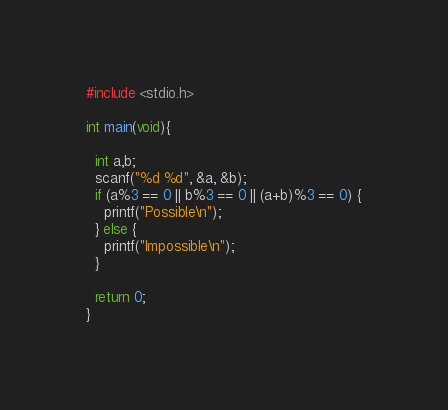Convert code to text. <code><loc_0><loc_0><loc_500><loc_500><_C_>#include <stdio.h>

int main(void){

  int a,b;
  scanf("%d %d", &a, &b);
  if (a%3 == 0 || b%3 == 0 || (a+b)%3 == 0) {
    printf("Possible\n");
  } else {
    printf("Impossible\n");
  }

  return 0;
}</code> 